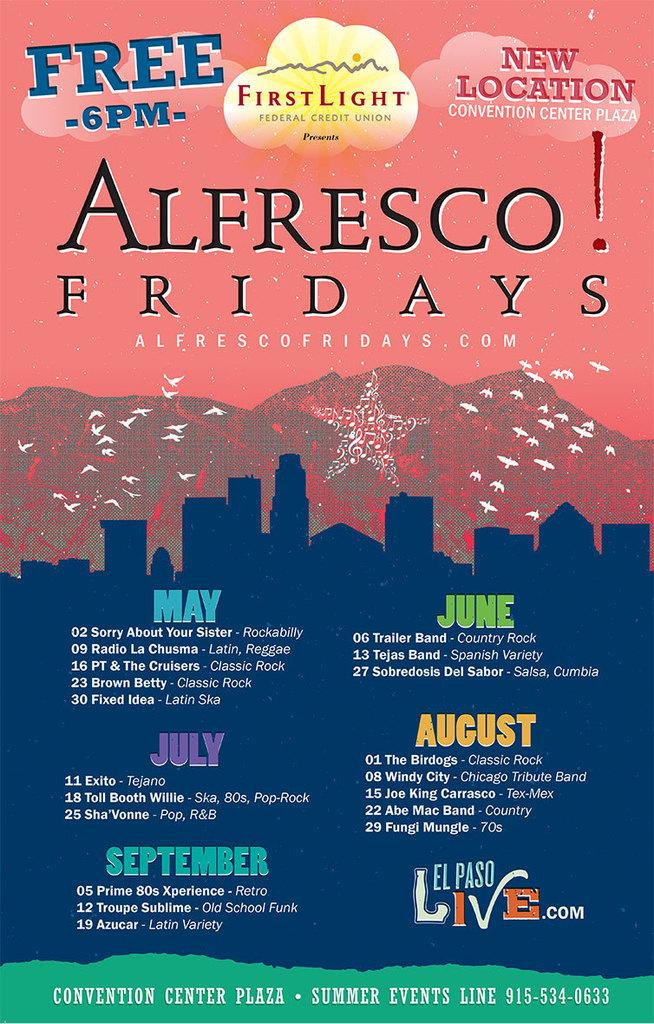Provide a one-sentence caption for the provided image. A poster detailing an event called Alfresco! Fridays that is a series of concerts at the Convention Center Plaza. 